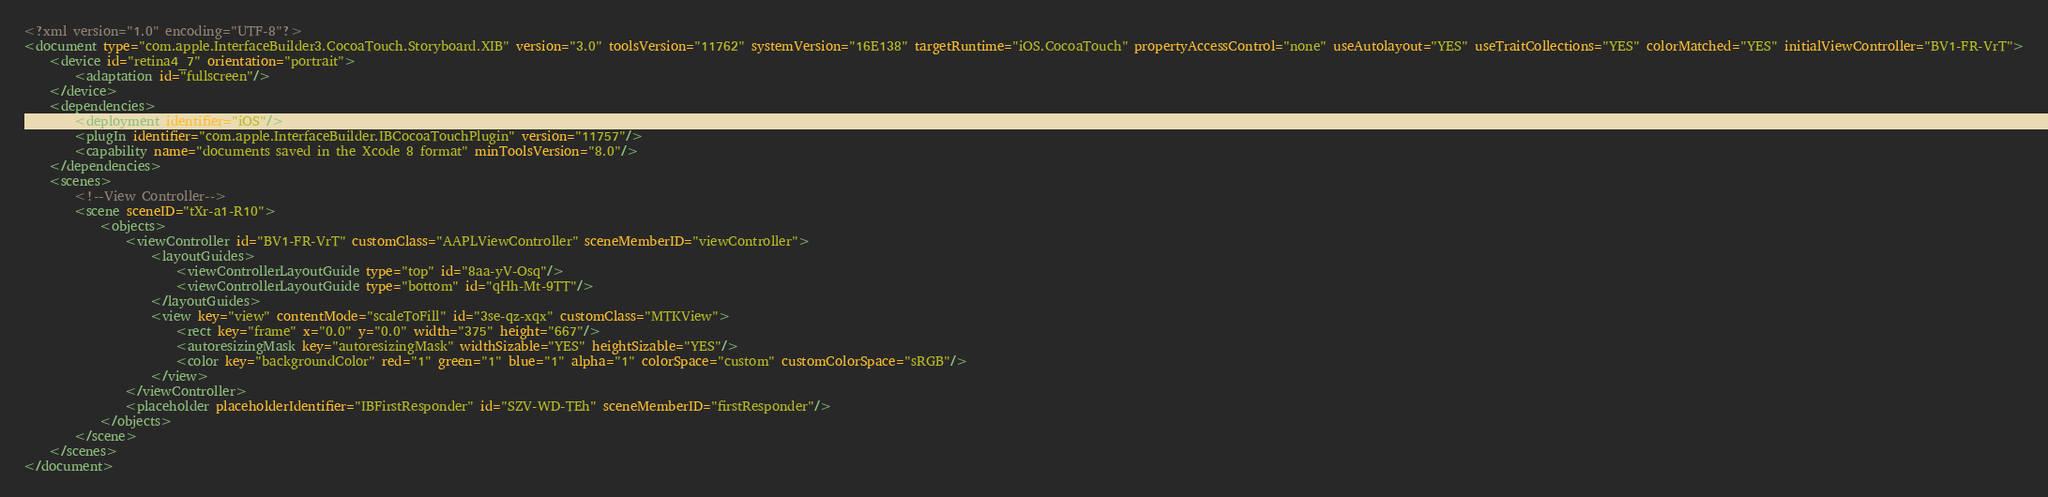Convert code to text. <code><loc_0><loc_0><loc_500><loc_500><_XML_><?xml version="1.0" encoding="UTF-8"?>
<document type="com.apple.InterfaceBuilder3.CocoaTouch.Storyboard.XIB" version="3.0" toolsVersion="11762" systemVersion="16E138" targetRuntime="iOS.CocoaTouch" propertyAccessControl="none" useAutolayout="YES" useTraitCollections="YES" colorMatched="YES" initialViewController="BV1-FR-VrT">
    <device id="retina4_7" orientation="portrait">
        <adaptation id="fullscreen"/>
    </device>
    <dependencies>
        <deployment identifier="iOS"/>
        <plugIn identifier="com.apple.InterfaceBuilder.IBCocoaTouchPlugin" version="11757"/>
        <capability name="documents saved in the Xcode 8 format" minToolsVersion="8.0"/>
    </dependencies>
    <scenes>
        <!--View Controller-->
        <scene sceneID="tXr-a1-R10">
            <objects>
                <viewController id="BV1-FR-VrT" customClass="AAPLViewController" sceneMemberID="viewController">
                    <layoutGuides>
                        <viewControllerLayoutGuide type="top" id="8aa-yV-Osq"/>
                        <viewControllerLayoutGuide type="bottom" id="qHh-Mt-9TT"/>
                    </layoutGuides>
                    <view key="view" contentMode="scaleToFill" id="3se-qz-xqx" customClass="MTKView">
                        <rect key="frame" x="0.0" y="0.0" width="375" height="667"/>
                        <autoresizingMask key="autoresizingMask" widthSizable="YES" heightSizable="YES"/>
                        <color key="backgroundColor" red="1" green="1" blue="1" alpha="1" colorSpace="custom" customColorSpace="sRGB"/>
                    </view>
                </viewController>
                <placeholder placeholderIdentifier="IBFirstResponder" id="SZV-WD-TEh" sceneMemberID="firstResponder"/>
            </objects>
        </scene>
    </scenes>
</document>
</code> 